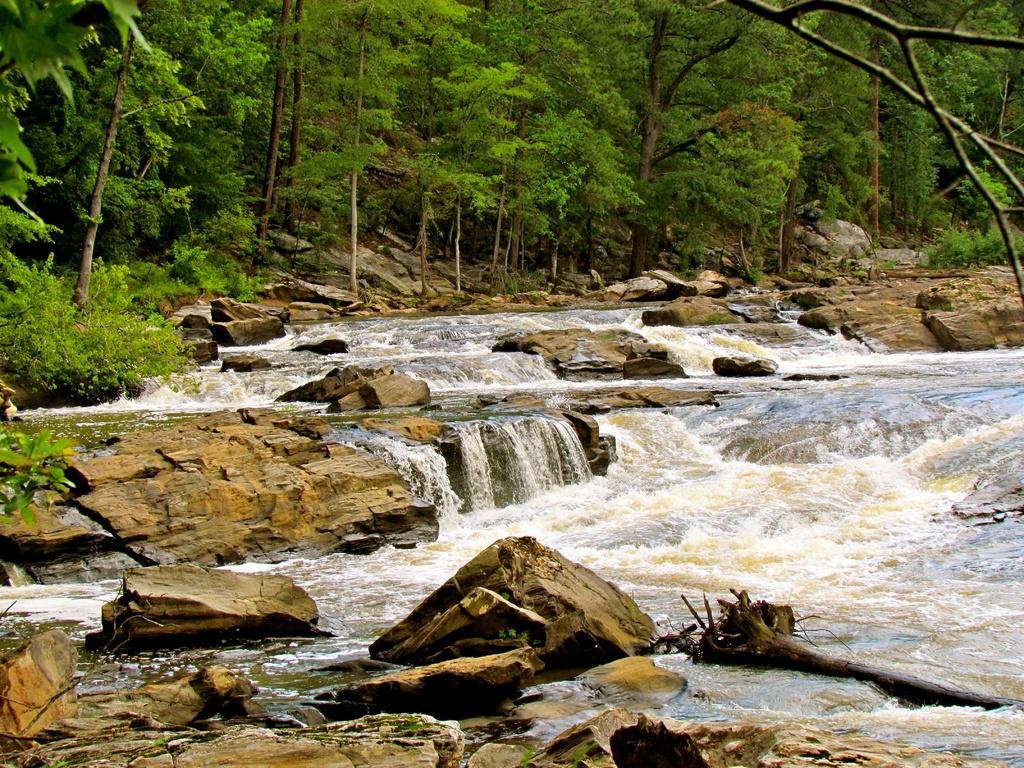Describe this image in one or two sentences. This image consists of water flowing. At the bottom, there are rocks and water. In the background, there are many trees. It looks like it is clicked in a forest. 